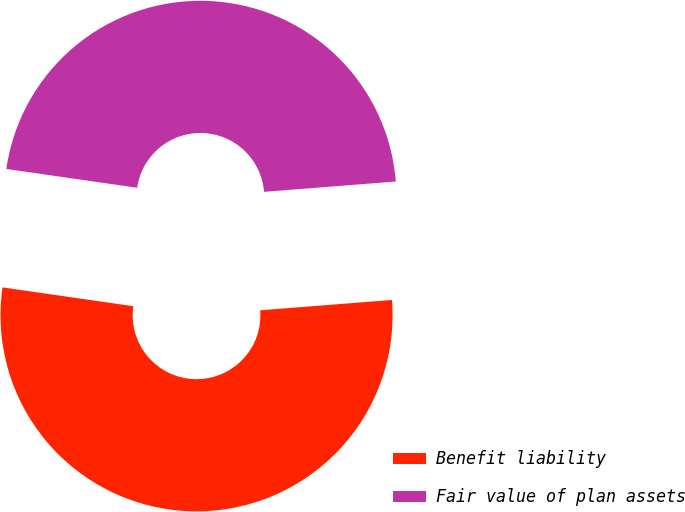<chart> <loc_0><loc_0><loc_500><loc_500><pie_chart><fcel>Benefit liability<fcel>Fair value of plan assets<nl><fcel>53.52%<fcel>46.48%<nl></chart> 